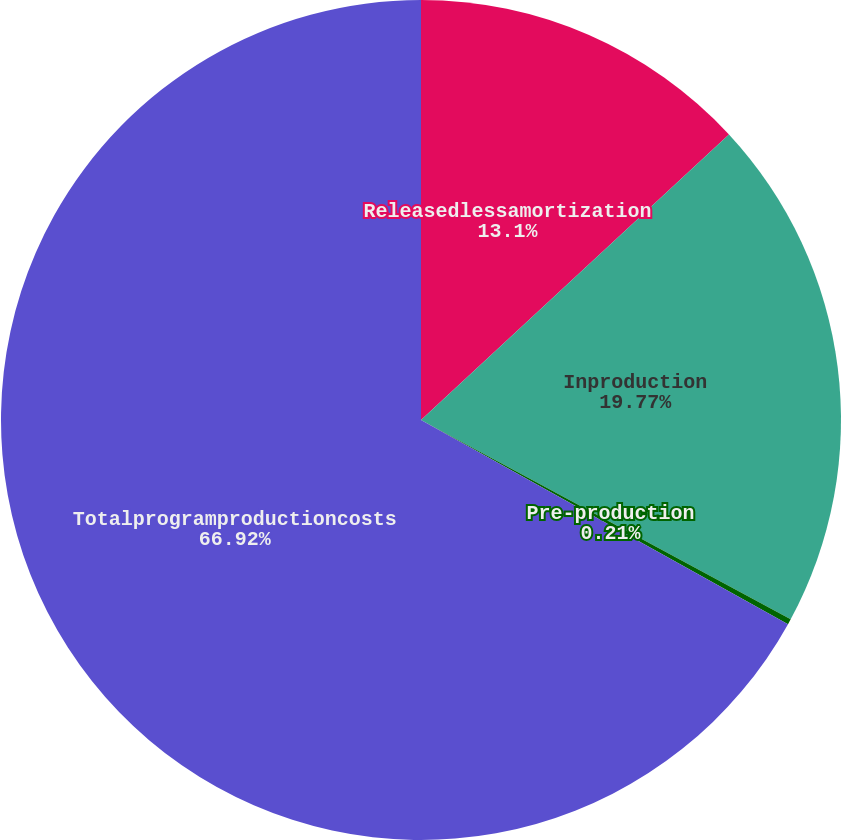Convert chart. <chart><loc_0><loc_0><loc_500><loc_500><pie_chart><fcel>Releasedlessamortization<fcel>Inproduction<fcel>Pre-production<fcel>Totalprogramproductioncosts<nl><fcel>13.1%<fcel>19.77%<fcel>0.21%<fcel>66.92%<nl></chart> 